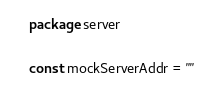<code> <loc_0><loc_0><loc_500><loc_500><_Go_>package server

const mockServerAddr = ""
</code> 